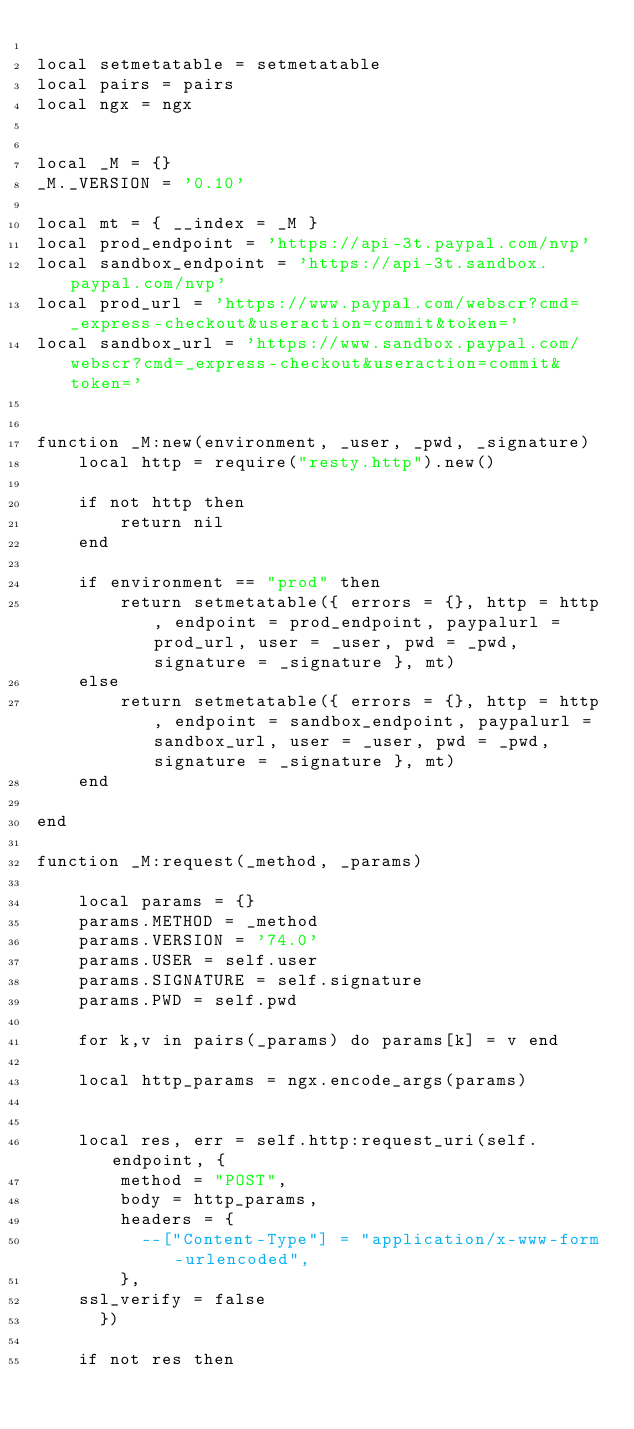Convert code to text. <code><loc_0><loc_0><loc_500><loc_500><_Lua_>
local setmetatable = setmetatable
local pairs = pairs
local ngx = ngx


local _M = {}
_M._VERSION = '0.10'

local mt = { __index = _M }
local prod_endpoint = 'https://api-3t.paypal.com/nvp'
local sandbox_endpoint = 'https://api-3t.sandbox.paypal.com/nvp'
local prod_url = 'https://www.paypal.com/webscr?cmd=_express-checkout&useraction=commit&token='
local sandbox_url = 'https://www.sandbox.paypal.com/webscr?cmd=_express-checkout&useraction=commit&token='


function _M:new(environment, _user, _pwd, _signature)
    local http = require("resty.http").new()
    
    if not http then
        return nil
    end
    
    if environment == "prod" then
        return setmetatable({ errors = {}, http = http, endpoint = prod_endpoint, paypalurl = prod_url, user = _user, pwd = _pwd, signature = _signature }, mt)
    else
        return setmetatable({ errors = {}, http = http, endpoint = sandbox_endpoint, paypalurl = sandbox_url, user = _user, pwd = _pwd, signature = _signature }, mt)
    end

end

function _M:request(_method, _params)
    
    local params = {}
    params.METHOD = _method
    params.VERSION = '74.0'
    params.USER = self.user
    params.SIGNATURE = self.signature
    params.PWD = self.pwd

    for k,v in pairs(_params) do params[k] = v end
        
    local http_params = ngx.encode_args(params)
    
    
    local res, err = self.http:request_uri(self.endpoint, {
        method = "POST",
        body = http_params,
        headers = {
          --["Content-Type"] = "application/x-www-form-urlencoded",
        },
	ssl_verify = false
      })

    if not res then</code> 